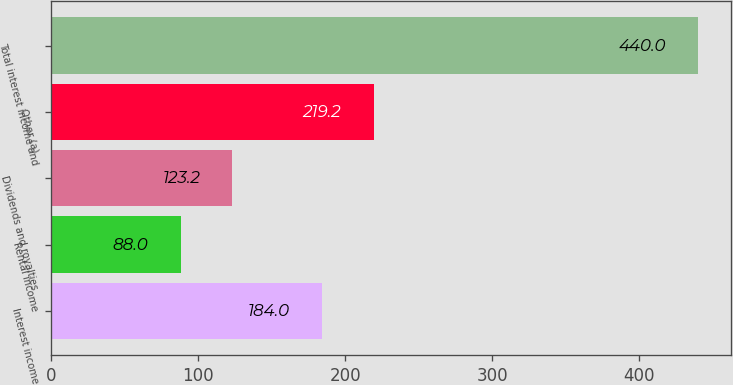Convert chart. <chart><loc_0><loc_0><loc_500><loc_500><bar_chart><fcel>Interest income<fcel>Rental income<fcel>Dividends and royalties<fcel>Other (a)<fcel>Total interest income and<nl><fcel>184<fcel>88<fcel>123.2<fcel>219.2<fcel>440<nl></chart> 